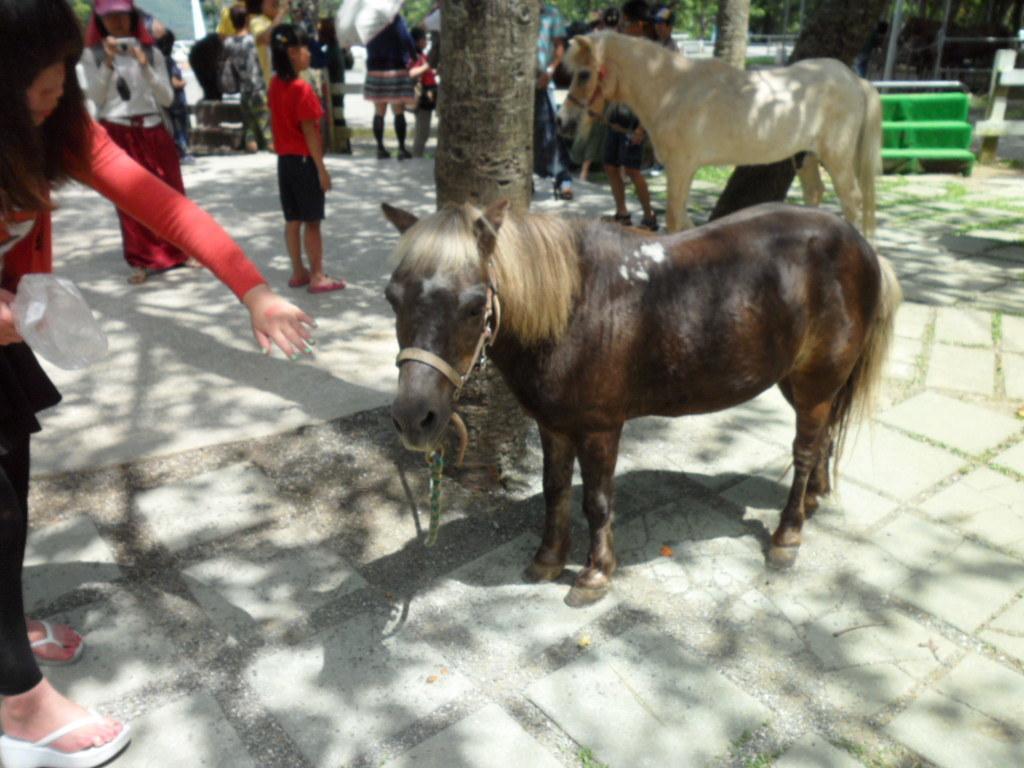Describe this image in one or two sentences. In this image I can see the group of people with different color dresses. I can see few animals which are in brown and black color. In the background I can see the trees and few objects. 